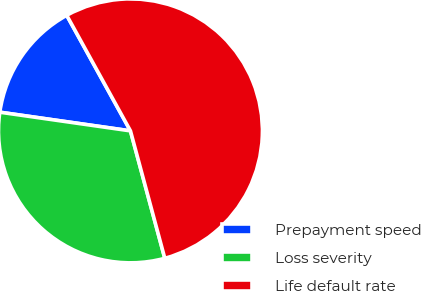<chart> <loc_0><loc_0><loc_500><loc_500><pie_chart><fcel>Prepayment speed<fcel>Loss severity<fcel>Life default rate<nl><fcel>14.72%<fcel>31.45%<fcel>53.83%<nl></chart> 